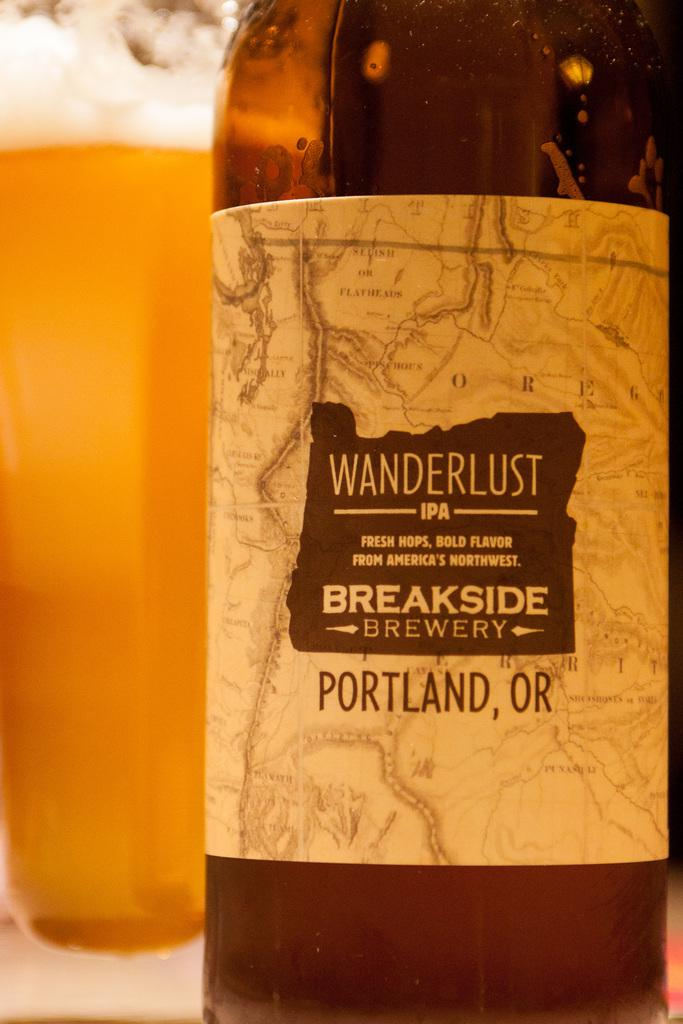What is the main object in the image? There is a beer glass in the image. Where is the beer glass located in the image? The beer glass is on the left side of the image. What other beer-related object can be seen in the image? There is a beer bottle in the image. Where is the beer bottle located in the image? The beer bottle is on the right side of the image. What type of toys can be seen in the image? There are no toys present in the image. What kind of apparel is the turkey wearing in the image? There is no turkey present in the image, and therefore no apparel can be associated with it. 